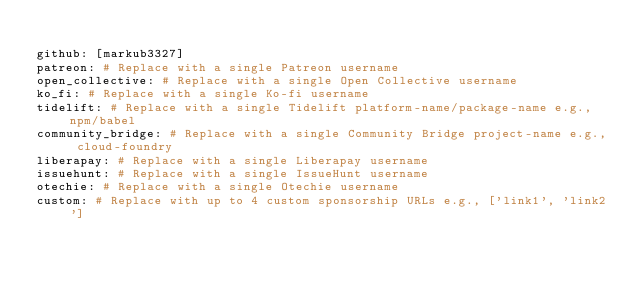<code> <loc_0><loc_0><loc_500><loc_500><_YAML_>
github: [markub3327]
patreon: # Replace with a single Patreon username
open_collective: # Replace with a single Open Collective username
ko_fi: # Replace with a single Ko-fi username
tidelift: # Replace with a single Tidelift platform-name/package-name e.g., npm/babel
community_bridge: # Replace with a single Community Bridge project-name e.g., cloud-foundry
liberapay: # Replace with a single Liberapay username
issuehunt: # Replace with a single IssueHunt username
otechie: # Replace with a single Otechie username
custom: # Replace with up to 4 custom sponsorship URLs e.g., ['link1', 'link2']
</code> 